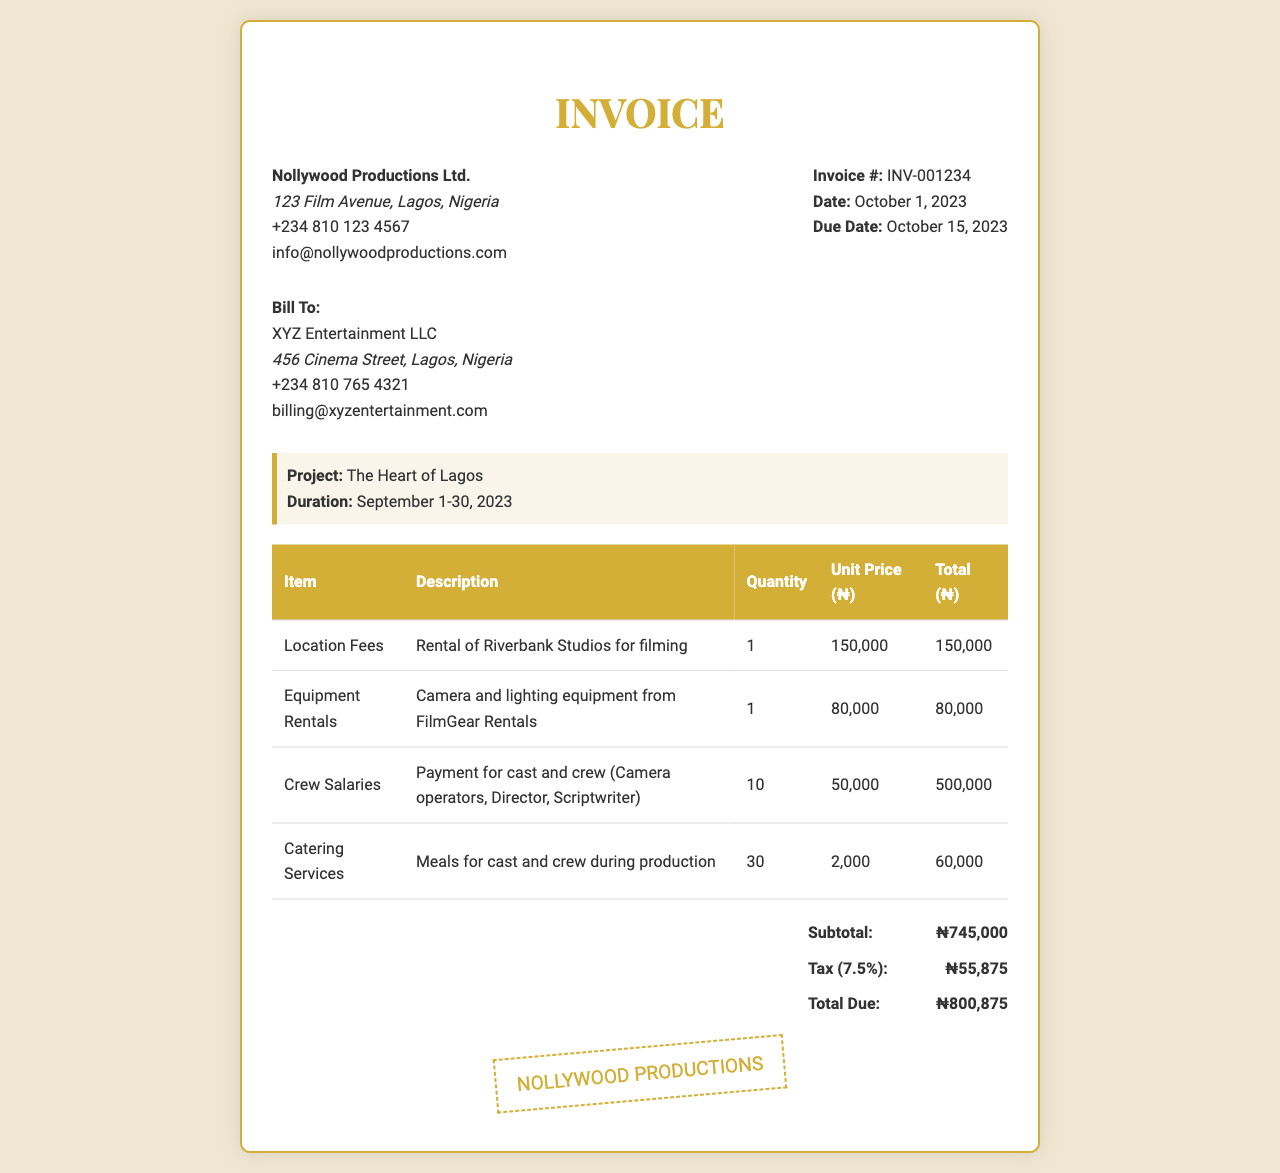what is the invoice number? The invoice number is clearly listed under the invoice header section as a unique identifier for the document.
Answer: INV-001234 what is the total due amount? The total due amount is provided in the total section of the document, summarizing all charges including applicable tax.
Answer: ₦800,875 what is the due date for payment? The due date is specified in the invoice header, indicating when the payment should be made.
Answer: October 15, 2023 how much were the crew salaries? The crew salaries are listed in the table along with their description and total cost, indicating the payment made to the cast and crew.
Answer: ₦500,000 what is the tax rate applied on the subtotal? The tax rate is indicated in the total section, specifying the percentage charged on the subtotal of the invoice.
Answer: 7.5% who is the bill recipient? The recipient's name is provided in the bill to section and identifies the entity responsible for payment.
Answer: XYZ Entertainment LLC what was the purpose of the location fees? The description provides insight into the intended use of the location fees as part of the film production process.
Answer: Rental of Riverbank Studios for filming how many crew members are accounted for in the salaries? The quantity of crew members included in the salaries section gives insight into the number of personnel involved.
Answer: 10 what is the subtotal of the invoice before tax? The subtotal provides a clear breakdown of the total cost before any tax is applied, summarizing all expenses.
Answer: ₦745,000 